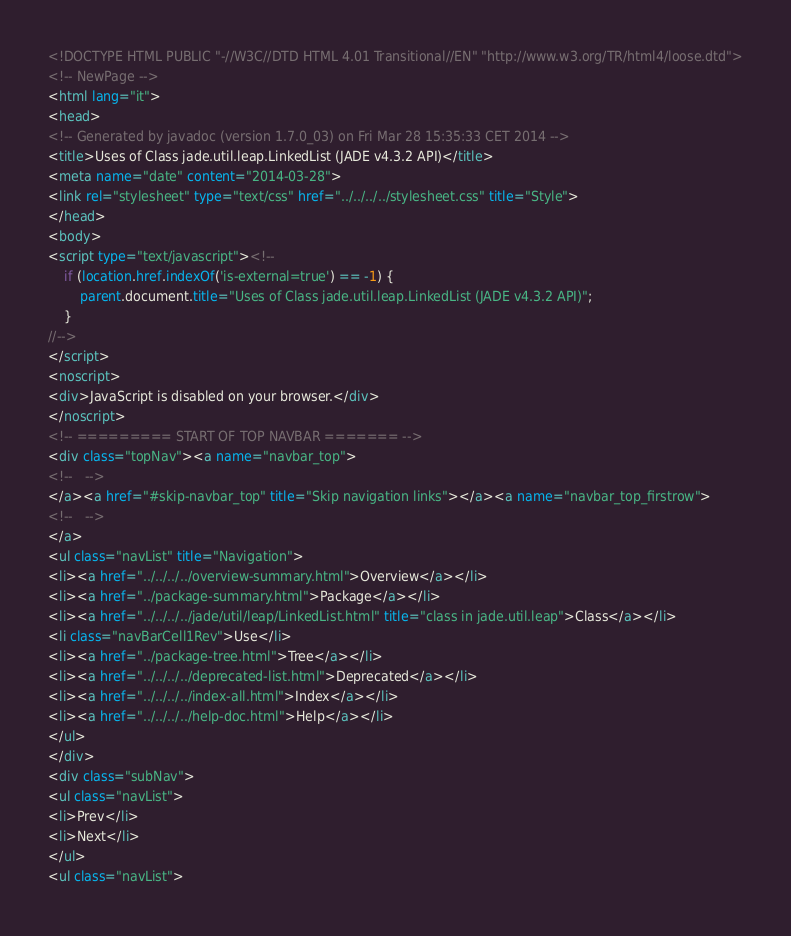Convert code to text. <code><loc_0><loc_0><loc_500><loc_500><_HTML_><!DOCTYPE HTML PUBLIC "-//W3C//DTD HTML 4.01 Transitional//EN" "http://www.w3.org/TR/html4/loose.dtd">
<!-- NewPage -->
<html lang="it">
<head>
<!-- Generated by javadoc (version 1.7.0_03) on Fri Mar 28 15:35:33 CET 2014 -->
<title>Uses of Class jade.util.leap.LinkedList (JADE v4.3.2 API)</title>
<meta name="date" content="2014-03-28">
<link rel="stylesheet" type="text/css" href="../../../../stylesheet.css" title="Style">
</head>
<body>
<script type="text/javascript"><!--
    if (location.href.indexOf('is-external=true') == -1) {
        parent.document.title="Uses of Class jade.util.leap.LinkedList (JADE v4.3.2 API)";
    }
//-->
</script>
<noscript>
<div>JavaScript is disabled on your browser.</div>
</noscript>
<!-- ========= START OF TOP NAVBAR ======= -->
<div class="topNav"><a name="navbar_top">
<!--   -->
</a><a href="#skip-navbar_top" title="Skip navigation links"></a><a name="navbar_top_firstrow">
<!--   -->
</a>
<ul class="navList" title="Navigation">
<li><a href="../../../../overview-summary.html">Overview</a></li>
<li><a href="../package-summary.html">Package</a></li>
<li><a href="../../../../jade/util/leap/LinkedList.html" title="class in jade.util.leap">Class</a></li>
<li class="navBarCell1Rev">Use</li>
<li><a href="../package-tree.html">Tree</a></li>
<li><a href="../../../../deprecated-list.html">Deprecated</a></li>
<li><a href="../../../../index-all.html">Index</a></li>
<li><a href="../../../../help-doc.html">Help</a></li>
</ul>
</div>
<div class="subNav">
<ul class="navList">
<li>Prev</li>
<li>Next</li>
</ul>
<ul class="navList"></code> 